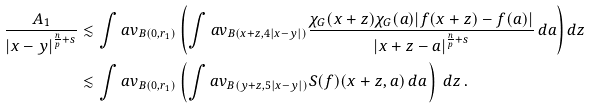<formula> <loc_0><loc_0><loc_500><loc_500>\frac { A _ { 1 } } { | x - y | ^ { \frac { n } { p } + s } } & \lesssim \int a v _ { B ( 0 , r _ { 1 } ) } \left ( \int a v _ { B ( x + z , 4 | x - y | ) } \frac { \chi _ { G } ( x + z ) \chi _ { G } ( a ) | f ( x + z ) - f ( a ) | } { | x + z - a | ^ { \frac { n } { p } + s } } \, d a \right ) d z \\ & \lesssim \int a v _ { B ( 0 , r _ { 1 } ) } \left ( \int a v _ { B ( y + z , 5 | x - y | ) } S ( f ) ( x + z , a ) \, d a \, \right ) \, d z \, .</formula> 